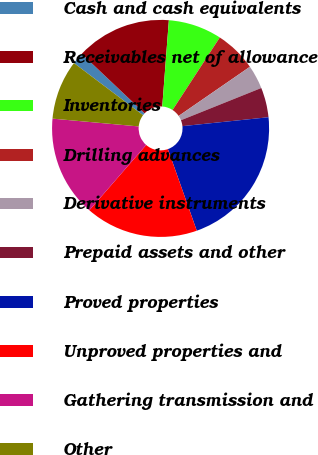<chart> <loc_0><loc_0><loc_500><loc_500><pie_chart><fcel>Cash and cash equivalents<fcel>Receivables net of allowance<fcel>Inventories<fcel>Drilling advances<fcel>Derivative instruments<fcel>Prepaid assets and other<fcel>Proved properties<fcel>Unproved properties and<fcel>Gathering transmission and<fcel>Other<nl><fcel>1.77%<fcel>14.16%<fcel>7.97%<fcel>6.2%<fcel>3.54%<fcel>4.43%<fcel>21.23%<fcel>16.81%<fcel>15.04%<fcel>8.85%<nl></chart> 